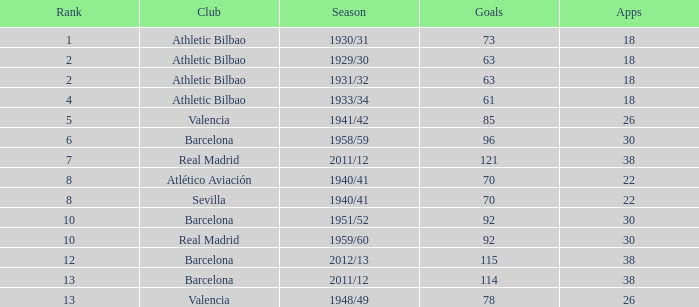What are the apps for less than 61 goals and before rank 6? None. 